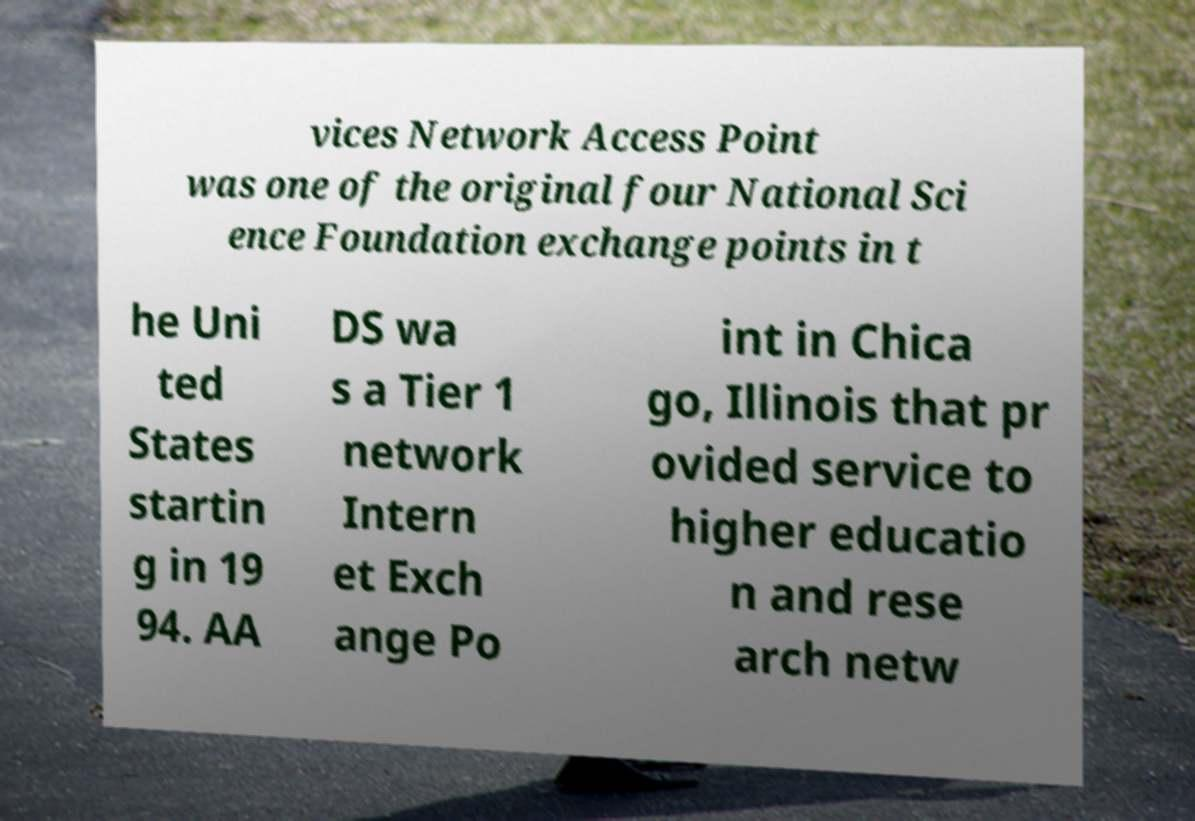Can you accurately transcribe the text from the provided image for me? vices Network Access Point was one of the original four National Sci ence Foundation exchange points in t he Uni ted States startin g in 19 94. AA DS wa s a Tier 1 network Intern et Exch ange Po int in Chica go, Illinois that pr ovided service to higher educatio n and rese arch netw 